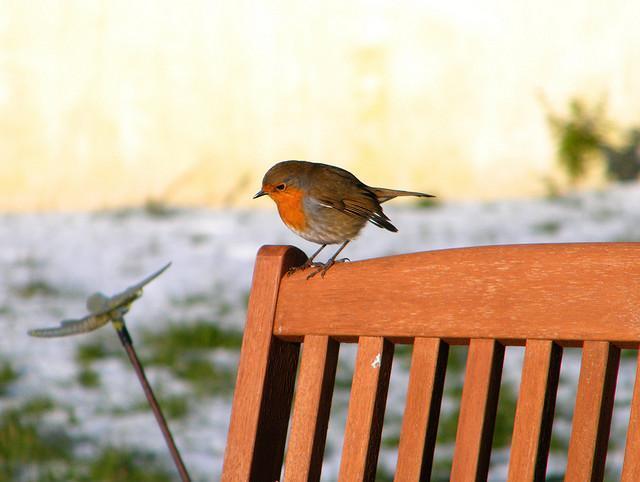How many birds are there?
Give a very brief answer. 1. How many buses are there?
Give a very brief answer. 0. 